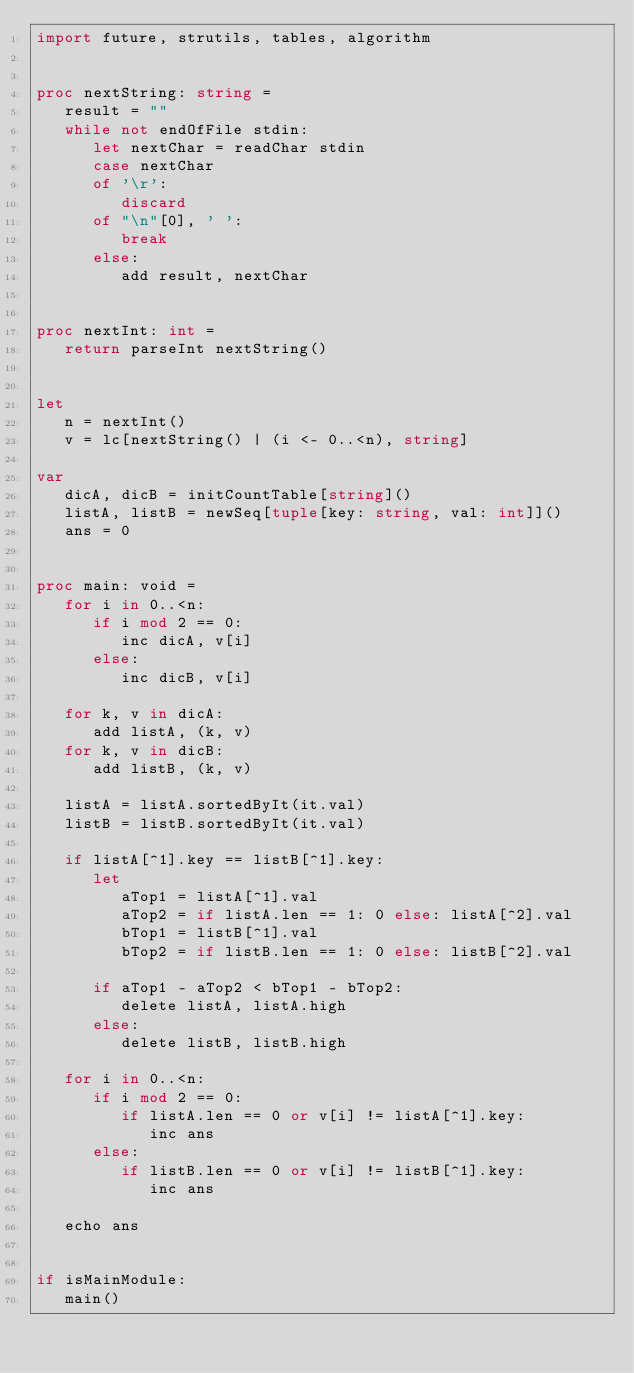<code> <loc_0><loc_0><loc_500><loc_500><_Nim_>import future, strutils, tables, algorithm


proc nextString: string =
   result = ""
   while not endOfFile stdin:
      let nextChar = readChar stdin
      case nextChar
      of '\r':
         discard
      of "\n"[0], ' ':
         break
      else:
         add result, nextChar


proc nextInt: int =
   return parseInt nextString()


let
   n = nextInt()
   v = lc[nextString() | (i <- 0..<n), string]

var
   dicA, dicB = initCountTable[string]()
   listA, listB = newSeq[tuple[key: string, val: int]]()
   ans = 0


proc main: void =
   for i in 0..<n:
      if i mod 2 == 0:
         inc dicA, v[i]
      else:
         inc dicB, v[i]

   for k, v in dicA:
      add listA, (k, v)
   for k, v in dicB:
      add listB, (k, v)

   listA = listA.sortedByIt(it.val)
   listB = listB.sortedByIt(it.val)

   if listA[^1].key == listB[^1].key:
      let
         aTop1 = listA[^1].val
         aTop2 = if listA.len == 1: 0 else: listA[^2].val
         bTop1 = listB[^1].val
         bTop2 = if listB.len == 1: 0 else: listB[^2].val   

      if aTop1 - aTop2 < bTop1 - bTop2:
         delete listA, listA.high
      else:
         delete listB, listB.high

   for i in 0..<n:
      if i mod 2 == 0:
         if listA.len == 0 or v[i] != listA[^1].key:
            inc ans
      else:
         if listB.len == 0 or v[i] != listB[^1].key:
            inc ans

   echo ans


if isMainModule:
   main()
</code> 